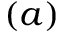Convert formula to latex. <formula><loc_0><loc_0><loc_500><loc_500>( a )</formula> 